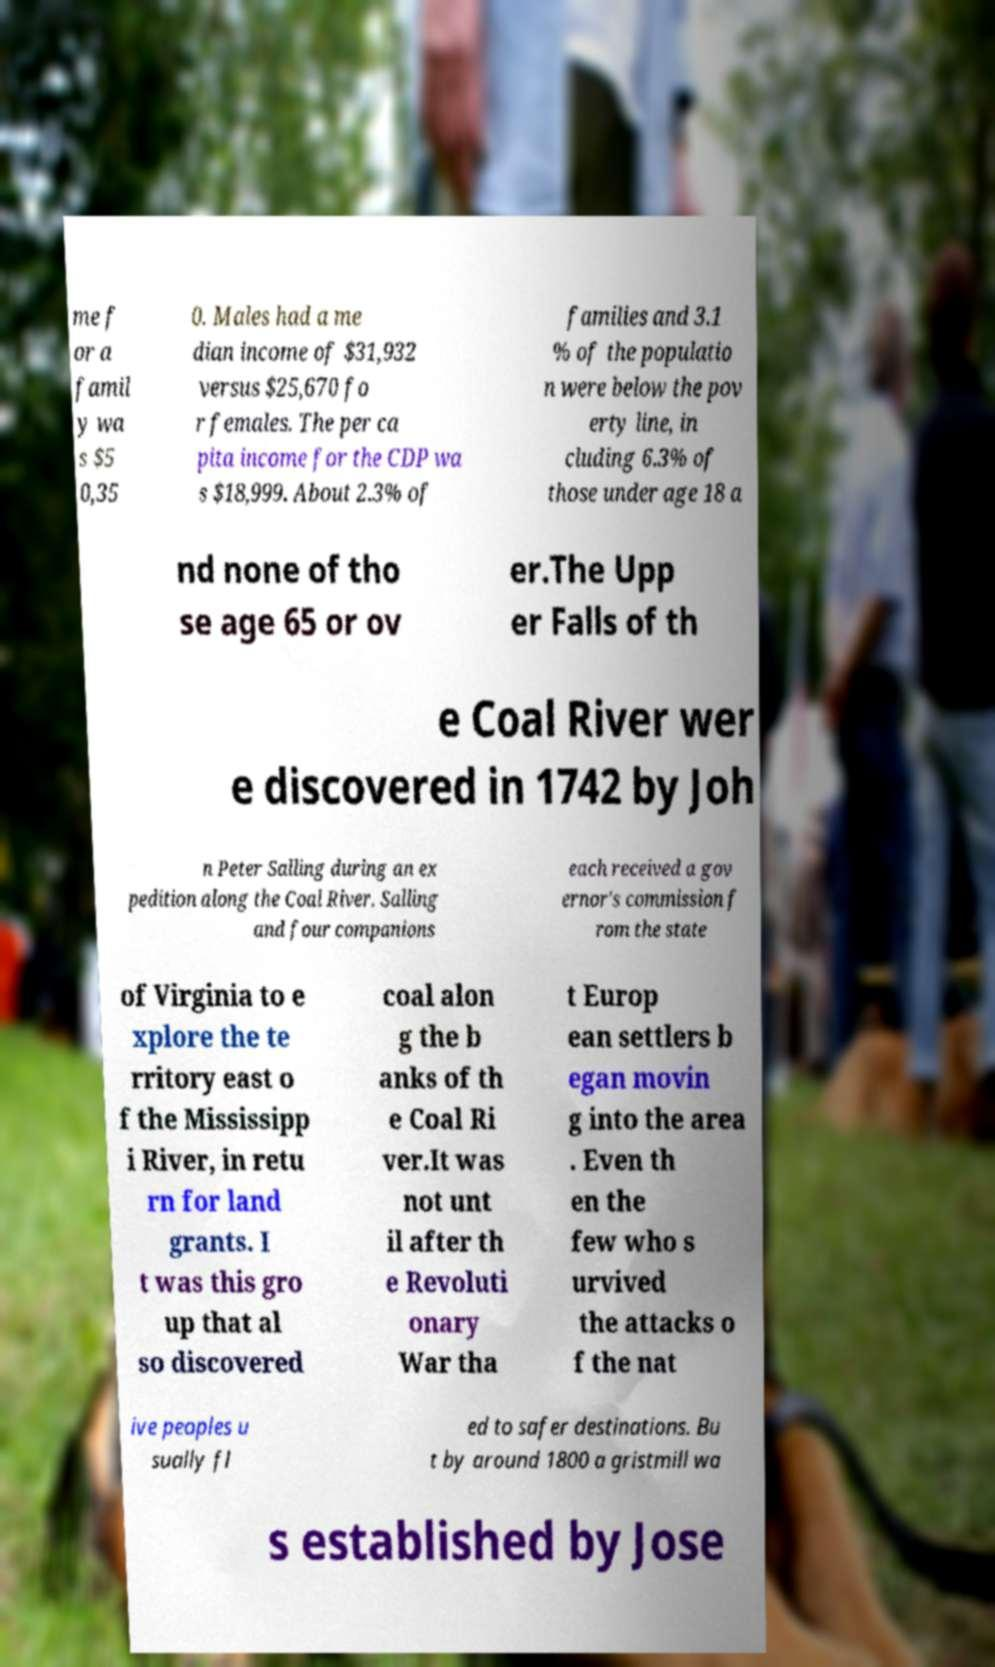Could you assist in decoding the text presented in this image and type it out clearly? me f or a famil y wa s $5 0,35 0. Males had a me dian income of $31,932 versus $25,670 fo r females. The per ca pita income for the CDP wa s $18,999. About 2.3% of families and 3.1 % of the populatio n were below the pov erty line, in cluding 6.3% of those under age 18 a nd none of tho se age 65 or ov er.The Upp er Falls of th e Coal River wer e discovered in 1742 by Joh n Peter Salling during an ex pedition along the Coal River. Salling and four companions each received a gov ernor's commission f rom the state of Virginia to e xplore the te rritory east o f the Mississipp i River, in retu rn for land grants. I t was this gro up that al so discovered coal alon g the b anks of th e Coal Ri ver.It was not unt il after th e Revoluti onary War tha t Europ ean settlers b egan movin g into the area . Even th en the few who s urvived the attacks o f the nat ive peoples u sually fl ed to safer destinations. Bu t by around 1800 a gristmill wa s established by Jose 